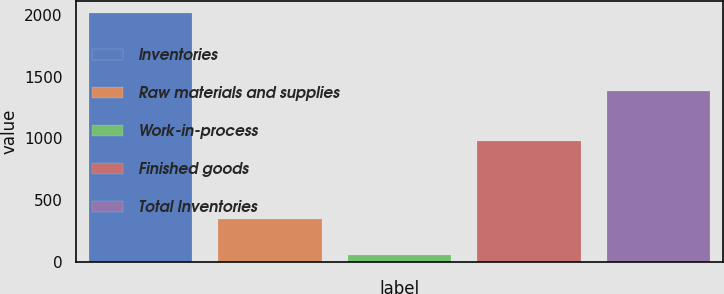Convert chart to OTSL. <chart><loc_0><loc_0><loc_500><loc_500><bar_chart><fcel>Inventories<fcel>Raw materials and supplies<fcel>Work-in-process<fcel>Finished goods<fcel>Total Inventories<nl><fcel>2014<fcel>349<fcel>55<fcel>978<fcel>1382<nl></chart> 